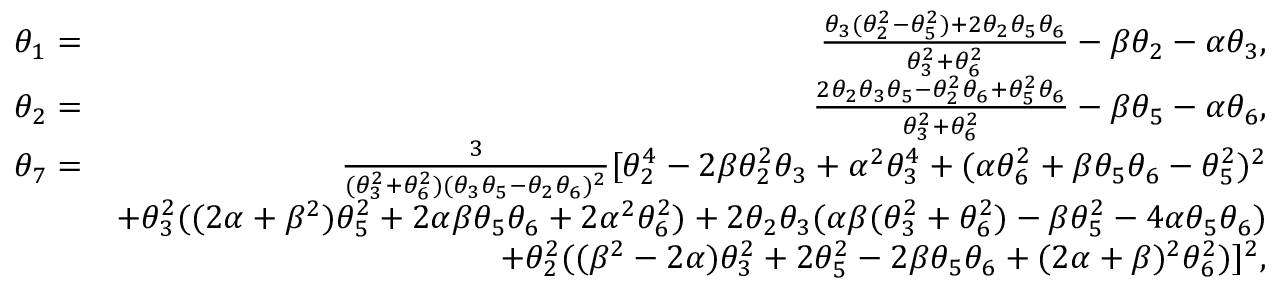<formula> <loc_0><loc_0><loc_500><loc_500>\begin{array} { r l r } & { \theta _ { 1 } = } & { \frac { \theta _ { 3 } ( \theta _ { 2 } ^ { 2 } - \theta _ { 5 } ^ { 2 } ) + 2 \theta _ { 2 } \theta _ { 5 } \theta _ { 6 } } { \theta _ { 3 } ^ { 2 } + \theta _ { 6 } ^ { 2 } } - \beta \theta _ { 2 } - \alpha \theta _ { 3 } , } \\ & { \theta _ { 2 } = } & { \frac { 2 \theta _ { 2 } \theta _ { 3 } \theta _ { 5 } - \theta _ { 2 } ^ { 2 } \theta _ { 6 } + \theta _ { 5 } ^ { 2 } \theta _ { 6 } } { \theta _ { 3 } ^ { 2 } + \theta _ { 6 } ^ { 2 } } - \beta \theta _ { 5 } - \alpha \theta _ { 6 } , } \\ & { \theta _ { 7 } = } & { \frac { 3 } { ( \theta _ { 3 } ^ { 2 } + \theta _ { 6 } ^ { 2 } ) ( \theta _ { 3 } \theta _ { 5 } - \theta _ { 2 } \theta _ { 6 } ) ^ { 2 } } [ \theta _ { 2 } ^ { 4 } - 2 \beta \theta _ { 2 } ^ { 2 } \theta _ { 3 } + \alpha ^ { 2 } \theta _ { 3 } ^ { 4 } + ( \alpha \theta _ { 6 } ^ { 2 } + \beta \theta _ { 5 } \theta _ { 6 } - \theta _ { 5 } ^ { 2 } ) ^ { 2 } } \\ & { + \theta _ { 3 } ^ { 2 } ( ( 2 \alpha + \beta ^ { 2 } ) \theta _ { 5 } ^ { 2 } + 2 \alpha \beta \theta _ { 5 } \theta _ { 6 } + 2 \alpha ^ { 2 } \theta _ { 6 } ^ { 2 } ) + 2 \theta _ { 2 } \theta _ { 3 } ( \alpha \beta ( \theta _ { 3 } ^ { 2 } + \theta _ { 6 } ^ { 2 } ) - \beta \theta _ { 5 } ^ { 2 } - 4 \alpha \theta _ { 5 } \theta _ { 6 } ) } \\ & { + \theta _ { 2 } ^ { 2 } ( ( \beta ^ { 2 } - 2 \alpha ) \theta _ { 3 } ^ { 2 } + 2 \theta _ { 5 } ^ { 2 } - 2 \beta \theta _ { 5 } \theta _ { 6 } + ( 2 \alpha + \beta ) ^ { 2 } \theta _ { 6 } ^ { 2 } ) ] ^ { 2 } , } \end{array}</formula> 